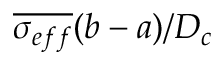Convert formula to latex. <formula><loc_0><loc_0><loc_500><loc_500>\overline { { \sigma _ { e f f } } } ( b - a ) / D _ { c }</formula> 